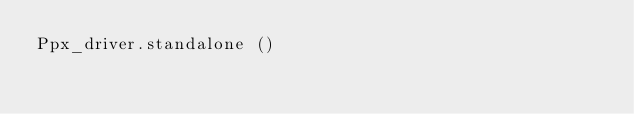Convert code to text. <code><loc_0><loc_0><loc_500><loc_500><_OCaml_>Ppx_driver.standalone ()
</code> 